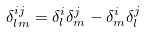<formula> <loc_0><loc_0><loc_500><loc_500>\delta _ { l m } ^ { i j } = \delta _ { l } ^ { i } \delta _ { m } ^ { j } - \delta _ { m } ^ { i } \delta _ { l } ^ { j }</formula> 